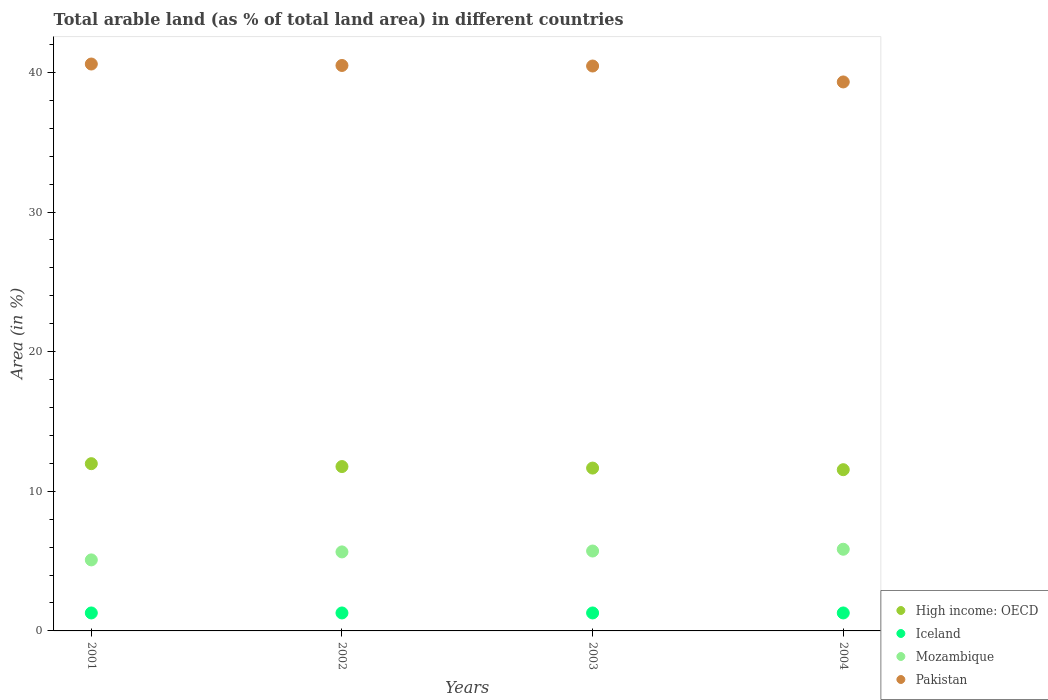What is the percentage of arable land in Mozambique in 2002?
Your answer should be compact. 5.66. Across all years, what is the maximum percentage of arable land in Pakistan?
Your answer should be very brief. 40.6. Across all years, what is the minimum percentage of arable land in Pakistan?
Offer a very short reply. 39.32. What is the total percentage of arable land in Iceland in the graph?
Offer a very short reply. 5.15. What is the difference between the percentage of arable land in Iceland in 2002 and that in 2003?
Your response must be concise. 0. What is the difference between the percentage of arable land in Iceland in 2003 and the percentage of arable land in Mozambique in 2001?
Keep it short and to the point. -3.8. What is the average percentage of arable land in Pakistan per year?
Provide a short and direct response. 40.22. In the year 2004, what is the difference between the percentage of arable land in Iceland and percentage of arable land in Mozambique?
Give a very brief answer. -4.56. What is the ratio of the percentage of arable land in Iceland in 2002 to that in 2003?
Keep it short and to the point. 1. What is the difference between the highest and the second highest percentage of arable land in Pakistan?
Your answer should be very brief. 0.1. What is the difference between the highest and the lowest percentage of arable land in Mozambique?
Offer a terse response. 0.76. Does the percentage of arable land in High income: OECD monotonically increase over the years?
Ensure brevity in your answer.  No. Is the percentage of arable land in Mozambique strictly greater than the percentage of arable land in High income: OECD over the years?
Make the answer very short. No. How many years are there in the graph?
Your answer should be compact. 4. Does the graph contain any zero values?
Your answer should be very brief. No. How many legend labels are there?
Ensure brevity in your answer.  4. How are the legend labels stacked?
Your answer should be very brief. Vertical. What is the title of the graph?
Your answer should be very brief. Total arable land (as % of total land area) in different countries. Does "Saudi Arabia" appear as one of the legend labels in the graph?
Offer a terse response. No. What is the label or title of the Y-axis?
Ensure brevity in your answer.  Area (in %). What is the Area (in %) of High income: OECD in 2001?
Your response must be concise. 11.98. What is the Area (in %) of Iceland in 2001?
Make the answer very short. 1.29. What is the Area (in %) of Mozambique in 2001?
Your answer should be compact. 5.09. What is the Area (in %) of Pakistan in 2001?
Give a very brief answer. 40.6. What is the Area (in %) in High income: OECD in 2002?
Make the answer very short. 11.77. What is the Area (in %) of Iceland in 2002?
Your answer should be compact. 1.29. What is the Area (in %) in Mozambique in 2002?
Ensure brevity in your answer.  5.66. What is the Area (in %) in Pakistan in 2002?
Offer a very short reply. 40.5. What is the Area (in %) in High income: OECD in 2003?
Provide a succinct answer. 11.66. What is the Area (in %) of Iceland in 2003?
Your answer should be very brief. 1.29. What is the Area (in %) of Mozambique in 2003?
Provide a succinct answer. 5.72. What is the Area (in %) of Pakistan in 2003?
Offer a very short reply. 40.46. What is the Area (in %) of High income: OECD in 2004?
Make the answer very short. 11.55. What is the Area (in %) in Iceland in 2004?
Ensure brevity in your answer.  1.29. What is the Area (in %) in Mozambique in 2004?
Provide a succinct answer. 5.85. What is the Area (in %) of Pakistan in 2004?
Your answer should be compact. 39.32. Across all years, what is the maximum Area (in %) of High income: OECD?
Your answer should be compact. 11.98. Across all years, what is the maximum Area (in %) in Iceland?
Ensure brevity in your answer.  1.29. Across all years, what is the maximum Area (in %) of Mozambique?
Your answer should be compact. 5.85. Across all years, what is the maximum Area (in %) in Pakistan?
Make the answer very short. 40.6. Across all years, what is the minimum Area (in %) of High income: OECD?
Your answer should be compact. 11.55. Across all years, what is the minimum Area (in %) in Iceland?
Make the answer very short. 1.29. Across all years, what is the minimum Area (in %) in Mozambique?
Your answer should be compact. 5.09. Across all years, what is the minimum Area (in %) in Pakistan?
Offer a terse response. 39.32. What is the total Area (in %) in High income: OECD in the graph?
Provide a succinct answer. 46.96. What is the total Area (in %) of Iceland in the graph?
Offer a terse response. 5.15. What is the total Area (in %) in Mozambique in the graph?
Offer a very short reply. 22.32. What is the total Area (in %) in Pakistan in the graph?
Provide a short and direct response. 160.88. What is the difference between the Area (in %) in High income: OECD in 2001 and that in 2002?
Ensure brevity in your answer.  0.21. What is the difference between the Area (in %) in Mozambique in 2001 and that in 2002?
Offer a terse response. -0.57. What is the difference between the Area (in %) in Pakistan in 2001 and that in 2002?
Ensure brevity in your answer.  0.1. What is the difference between the Area (in %) in High income: OECD in 2001 and that in 2003?
Make the answer very short. 0.32. What is the difference between the Area (in %) of Iceland in 2001 and that in 2003?
Your response must be concise. 0. What is the difference between the Area (in %) of Mozambique in 2001 and that in 2003?
Ensure brevity in your answer.  -0.64. What is the difference between the Area (in %) of Pakistan in 2001 and that in 2003?
Your answer should be compact. 0.14. What is the difference between the Area (in %) of High income: OECD in 2001 and that in 2004?
Your response must be concise. 0.43. What is the difference between the Area (in %) in Iceland in 2001 and that in 2004?
Ensure brevity in your answer.  0. What is the difference between the Area (in %) in Mozambique in 2001 and that in 2004?
Ensure brevity in your answer.  -0.76. What is the difference between the Area (in %) in Pakistan in 2001 and that in 2004?
Provide a succinct answer. 1.28. What is the difference between the Area (in %) of High income: OECD in 2002 and that in 2003?
Offer a terse response. 0.11. What is the difference between the Area (in %) in Iceland in 2002 and that in 2003?
Keep it short and to the point. 0. What is the difference between the Area (in %) in Mozambique in 2002 and that in 2003?
Provide a short and direct response. -0.06. What is the difference between the Area (in %) of Pakistan in 2002 and that in 2003?
Provide a short and direct response. 0.04. What is the difference between the Area (in %) in High income: OECD in 2002 and that in 2004?
Your answer should be compact. 0.22. What is the difference between the Area (in %) in Mozambique in 2002 and that in 2004?
Ensure brevity in your answer.  -0.19. What is the difference between the Area (in %) of Pakistan in 2002 and that in 2004?
Offer a very short reply. 1.18. What is the difference between the Area (in %) of High income: OECD in 2003 and that in 2004?
Offer a very short reply. 0.12. What is the difference between the Area (in %) in Mozambique in 2003 and that in 2004?
Provide a short and direct response. -0.13. What is the difference between the Area (in %) in Pakistan in 2003 and that in 2004?
Give a very brief answer. 1.14. What is the difference between the Area (in %) in High income: OECD in 2001 and the Area (in %) in Iceland in 2002?
Offer a very short reply. 10.69. What is the difference between the Area (in %) in High income: OECD in 2001 and the Area (in %) in Mozambique in 2002?
Make the answer very short. 6.32. What is the difference between the Area (in %) in High income: OECD in 2001 and the Area (in %) in Pakistan in 2002?
Provide a succinct answer. -28.52. What is the difference between the Area (in %) of Iceland in 2001 and the Area (in %) of Mozambique in 2002?
Keep it short and to the point. -4.37. What is the difference between the Area (in %) in Iceland in 2001 and the Area (in %) in Pakistan in 2002?
Your answer should be compact. -39.21. What is the difference between the Area (in %) of Mozambique in 2001 and the Area (in %) of Pakistan in 2002?
Provide a short and direct response. -35.41. What is the difference between the Area (in %) of High income: OECD in 2001 and the Area (in %) of Iceland in 2003?
Offer a very short reply. 10.69. What is the difference between the Area (in %) of High income: OECD in 2001 and the Area (in %) of Mozambique in 2003?
Give a very brief answer. 6.26. What is the difference between the Area (in %) of High income: OECD in 2001 and the Area (in %) of Pakistan in 2003?
Offer a terse response. -28.48. What is the difference between the Area (in %) of Iceland in 2001 and the Area (in %) of Mozambique in 2003?
Provide a succinct answer. -4.44. What is the difference between the Area (in %) in Iceland in 2001 and the Area (in %) in Pakistan in 2003?
Ensure brevity in your answer.  -39.17. What is the difference between the Area (in %) in Mozambique in 2001 and the Area (in %) in Pakistan in 2003?
Provide a succinct answer. -35.37. What is the difference between the Area (in %) of High income: OECD in 2001 and the Area (in %) of Iceland in 2004?
Offer a terse response. 10.69. What is the difference between the Area (in %) of High income: OECD in 2001 and the Area (in %) of Mozambique in 2004?
Offer a very short reply. 6.13. What is the difference between the Area (in %) of High income: OECD in 2001 and the Area (in %) of Pakistan in 2004?
Your response must be concise. -27.34. What is the difference between the Area (in %) of Iceland in 2001 and the Area (in %) of Mozambique in 2004?
Your answer should be very brief. -4.56. What is the difference between the Area (in %) of Iceland in 2001 and the Area (in %) of Pakistan in 2004?
Your response must be concise. -38.03. What is the difference between the Area (in %) of Mozambique in 2001 and the Area (in %) of Pakistan in 2004?
Ensure brevity in your answer.  -34.23. What is the difference between the Area (in %) in High income: OECD in 2002 and the Area (in %) in Iceland in 2003?
Provide a short and direct response. 10.49. What is the difference between the Area (in %) of High income: OECD in 2002 and the Area (in %) of Mozambique in 2003?
Your answer should be compact. 6.05. What is the difference between the Area (in %) in High income: OECD in 2002 and the Area (in %) in Pakistan in 2003?
Ensure brevity in your answer.  -28.69. What is the difference between the Area (in %) of Iceland in 2002 and the Area (in %) of Mozambique in 2003?
Your answer should be compact. -4.44. What is the difference between the Area (in %) of Iceland in 2002 and the Area (in %) of Pakistan in 2003?
Give a very brief answer. -39.17. What is the difference between the Area (in %) in Mozambique in 2002 and the Area (in %) in Pakistan in 2003?
Provide a short and direct response. -34.8. What is the difference between the Area (in %) in High income: OECD in 2002 and the Area (in %) in Iceland in 2004?
Offer a very short reply. 10.49. What is the difference between the Area (in %) of High income: OECD in 2002 and the Area (in %) of Mozambique in 2004?
Your response must be concise. 5.92. What is the difference between the Area (in %) in High income: OECD in 2002 and the Area (in %) in Pakistan in 2004?
Your answer should be very brief. -27.55. What is the difference between the Area (in %) of Iceland in 2002 and the Area (in %) of Mozambique in 2004?
Your answer should be very brief. -4.56. What is the difference between the Area (in %) in Iceland in 2002 and the Area (in %) in Pakistan in 2004?
Offer a terse response. -38.03. What is the difference between the Area (in %) in Mozambique in 2002 and the Area (in %) in Pakistan in 2004?
Give a very brief answer. -33.66. What is the difference between the Area (in %) of High income: OECD in 2003 and the Area (in %) of Iceland in 2004?
Offer a terse response. 10.38. What is the difference between the Area (in %) of High income: OECD in 2003 and the Area (in %) of Mozambique in 2004?
Your answer should be compact. 5.81. What is the difference between the Area (in %) in High income: OECD in 2003 and the Area (in %) in Pakistan in 2004?
Give a very brief answer. -27.66. What is the difference between the Area (in %) in Iceland in 2003 and the Area (in %) in Mozambique in 2004?
Ensure brevity in your answer.  -4.56. What is the difference between the Area (in %) in Iceland in 2003 and the Area (in %) in Pakistan in 2004?
Ensure brevity in your answer.  -38.03. What is the difference between the Area (in %) of Mozambique in 2003 and the Area (in %) of Pakistan in 2004?
Offer a terse response. -33.6. What is the average Area (in %) in High income: OECD per year?
Give a very brief answer. 11.74. What is the average Area (in %) of Iceland per year?
Make the answer very short. 1.29. What is the average Area (in %) in Mozambique per year?
Offer a very short reply. 5.58. What is the average Area (in %) in Pakistan per year?
Provide a succinct answer. 40.22. In the year 2001, what is the difference between the Area (in %) in High income: OECD and Area (in %) in Iceland?
Keep it short and to the point. 10.69. In the year 2001, what is the difference between the Area (in %) in High income: OECD and Area (in %) in Mozambique?
Give a very brief answer. 6.89. In the year 2001, what is the difference between the Area (in %) of High income: OECD and Area (in %) of Pakistan?
Keep it short and to the point. -28.62. In the year 2001, what is the difference between the Area (in %) of Iceland and Area (in %) of Mozambique?
Provide a succinct answer. -3.8. In the year 2001, what is the difference between the Area (in %) in Iceland and Area (in %) in Pakistan?
Provide a short and direct response. -39.32. In the year 2001, what is the difference between the Area (in %) of Mozambique and Area (in %) of Pakistan?
Make the answer very short. -35.52. In the year 2002, what is the difference between the Area (in %) in High income: OECD and Area (in %) in Iceland?
Provide a succinct answer. 10.49. In the year 2002, what is the difference between the Area (in %) in High income: OECD and Area (in %) in Mozambique?
Ensure brevity in your answer.  6.11. In the year 2002, what is the difference between the Area (in %) of High income: OECD and Area (in %) of Pakistan?
Offer a terse response. -28.73. In the year 2002, what is the difference between the Area (in %) in Iceland and Area (in %) in Mozambique?
Give a very brief answer. -4.37. In the year 2002, what is the difference between the Area (in %) of Iceland and Area (in %) of Pakistan?
Ensure brevity in your answer.  -39.21. In the year 2002, what is the difference between the Area (in %) of Mozambique and Area (in %) of Pakistan?
Your response must be concise. -34.84. In the year 2003, what is the difference between the Area (in %) of High income: OECD and Area (in %) of Iceland?
Offer a terse response. 10.38. In the year 2003, what is the difference between the Area (in %) in High income: OECD and Area (in %) in Mozambique?
Offer a terse response. 5.94. In the year 2003, what is the difference between the Area (in %) of High income: OECD and Area (in %) of Pakistan?
Make the answer very short. -28.8. In the year 2003, what is the difference between the Area (in %) in Iceland and Area (in %) in Mozambique?
Your answer should be compact. -4.44. In the year 2003, what is the difference between the Area (in %) in Iceland and Area (in %) in Pakistan?
Your answer should be compact. -39.17. In the year 2003, what is the difference between the Area (in %) in Mozambique and Area (in %) in Pakistan?
Make the answer very short. -34.74. In the year 2004, what is the difference between the Area (in %) in High income: OECD and Area (in %) in Iceland?
Provide a short and direct response. 10.26. In the year 2004, what is the difference between the Area (in %) in High income: OECD and Area (in %) in Mozambique?
Provide a short and direct response. 5.7. In the year 2004, what is the difference between the Area (in %) in High income: OECD and Area (in %) in Pakistan?
Offer a terse response. -27.77. In the year 2004, what is the difference between the Area (in %) in Iceland and Area (in %) in Mozambique?
Provide a succinct answer. -4.56. In the year 2004, what is the difference between the Area (in %) of Iceland and Area (in %) of Pakistan?
Your answer should be compact. -38.03. In the year 2004, what is the difference between the Area (in %) in Mozambique and Area (in %) in Pakistan?
Your answer should be compact. -33.47. What is the ratio of the Area (in %) in High income: OECD in 2001 to that in 2002?
Your answer should be compact. 1.02. What is the ratio of the Area (in %) in Iceland in 2001 to that in 2002?
Your response must be concise. 1. What is the ratio of the Area (in %) in Mozambique in 2001 to that in 2002?
Offer a terse response. 0.9. What is the ratio of the Area (in %) of High income: OECD in 2001 to that in 2003?
Your answer should be compact. 1.03. What is the ratio of the Area (in %) in Iceland in 2001 to that in 2003?
Provide a succinct answer. 1. What is the ratio of the Area (in %) in Mozambique in 2001 to that in 2003?
Offer a very short reply. 0.89. What is the ratio of the Area (in %) of Pakistan in 2001 to that in 2003?
Give a very brief answer. 1. What is the ratio of the Area (in %) of High income: OECD in 2001 to that in 2004?
Give a very brief answer. 1.04. What is the ratio of the Area (in %) in Mozambique in 2001 to that in 2004?
Provide a short and direct response. 0.87. What is the ratio of the Area (in %) of Pakistan in 2001 to that in 2004?
Your response must be concise. 1.03. What is the ratio of the Area (in %) of High income: OECD in 2002 to that in 2003?
Your answer should be very brief. 1.01. What is the ratio of the Area (in %) in Mozambique in 2002 to that in 2003?
Your response must be concise. 0.99. What is the ratio of the Area (in %) in Pakistan in 2002 to that in 2003?
Provide a succinct answer. 1. What is the ratio of the Area (in %) of High income: OECD in 2002 to that in 2004?
Keep it short and to the point. 1.02. What is the ratio of the Area (in %) in Mozambique in 2002 to that in 2004?
Your response must be concise. 0.97. What is the ratio of the Area (in %) in Iceland in 2003 to that in 2004?
Provide a succinct answer. 1. What is the ratio of the Area (in %) in Mozambique in 2003 to that in 2004?
Your answer should be very brief. 0.98. What is the difference between the highest and the second highest Area (in %) of High income: OECD?
Offer a very short reply. 0.21. What is the difference between the highest and the second highest Area (in %) of Iceland?
Ensure brevity in your answer.  0. What is the difference between the highest and the second highest Area (in %) in Mozambique?
Give a very brief answer. 0.13. What is the difference between the highest and the second highest Area (in %) in Pakistan?
Provide a succinct answer. 0.1. What is the difference between the highest and the lowest Area (in %) of High income: OECD?
Your answer should be very brief. 0.43. What is the difference between the highest and the lowest Area (in %) in Iceland?
Provide a succinct answer. 0. What is the difference between the highest and the lowest Area (in %) in Mozambique?
Your answer should be very brief. 0.76. What is the difference between the highest and the lowest Area (in %) in Pakistan?
Provide a short and direct response. 1.28. 